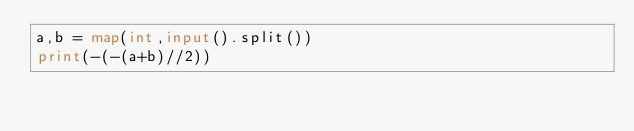Convert code to text. <code><loc_0><loc_0><loc_500><loc_500><_Python_>a,b = map(int,input().split())
print(-(-(a+b)//2))</code> 